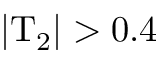Convert formula to latex. <formula><loc_0><loc_0><loc_500><loc_500>| T _ { 2 } | > 0 . 4</formula> 